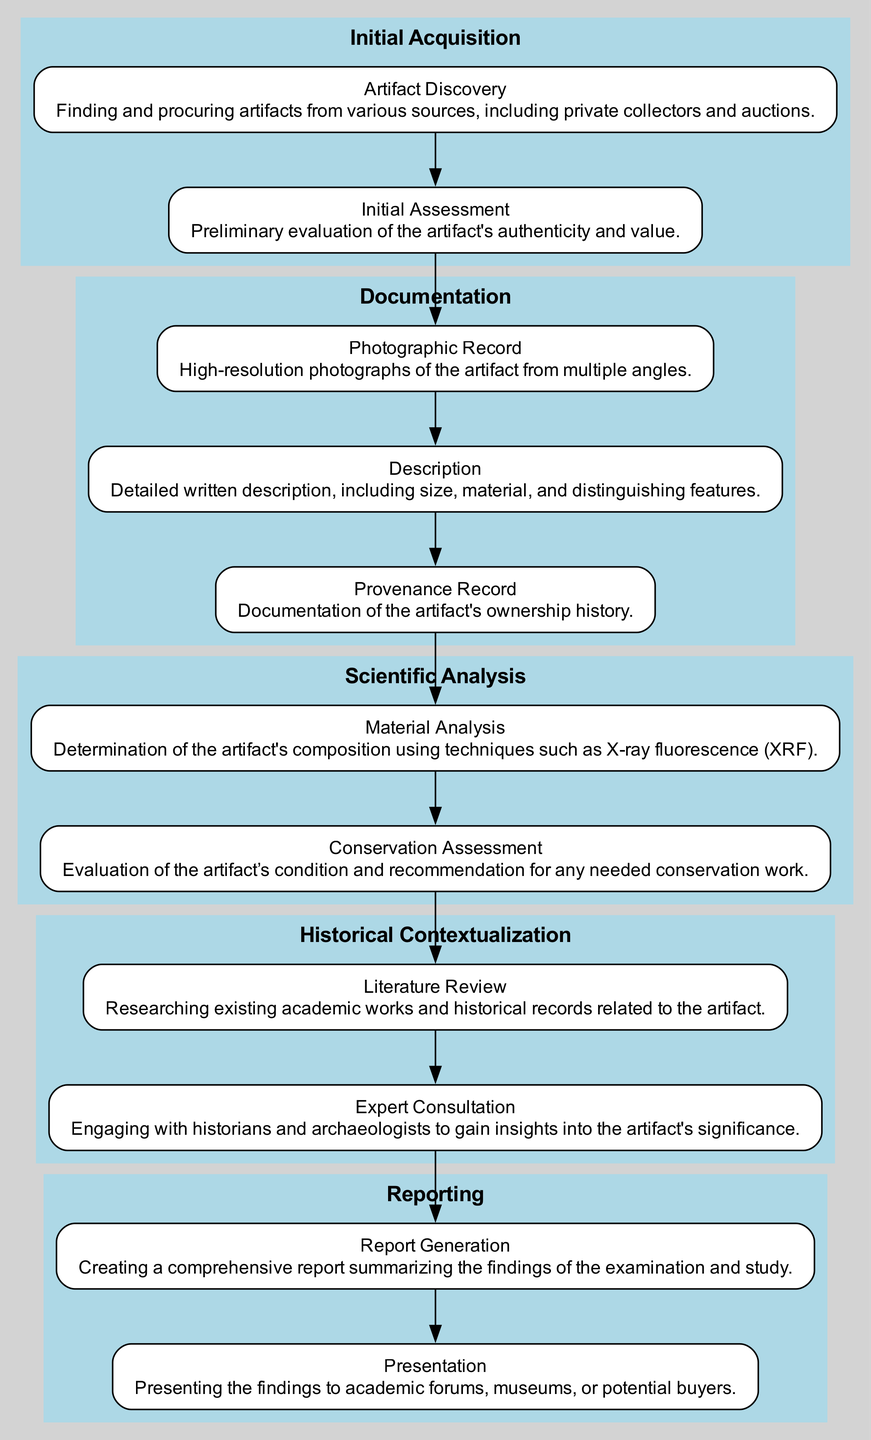What is the first step in the workflow? The initial step in the workflow as shown in the diagram is "Artifact Discovery," which is indicated as the first node in the "Initial Acquisition" element.
Answer: Artifact Discovery How many steps are there in the "Documentation" section? In the "Documentation" section of the diagram, there are three steps listed: "Photographic Record," "Description," and "Provenance Record." Thus, the total is three steps.
Answer: 3 Which element comes after "Scientific Analysis" in the workflow? Following "Scientific Analysis" in the workflow is the "Historical Contextualization" element, which is connected directly by an edge in the diagram.
Answer: Historical Contextualization What is the last step in the "Reporting" phase? The last step in the "Reporting" phase is "Presentation," which is indicated as the final node in that section.
Answer: Presentation How many elements are included in the entire workflow? The entire workflow consists of five elements: "Initial Acquisition," "Documentation," "Scientific Analysis," "Historical Contextualization," and "Reporting." Therefore, the total count is five elements.
Answer: 5 What type of analysis is included in the "Scientific Analysis" section? The "Scientific Analysis" section includes "Material Analysis" and "Conservation Assessment," indicating the technical examinations being performed.
Answer: Material Analysis Which two steps are linked directly within the "Documentation" element? The two steps linked directly within the "Documentation" element are "Photographic Record," and "Description," as indicated by an edge connecting them in the diagram.
Answer: Photographic Record and Description What action follows "Literature Review" in the "Historical Contextualization" phase? The action that follows "Literature Review" is "Expert Consultation," which is the next step in the flow of that phase as shown in the diagram.
Answer: Expert Consultation 